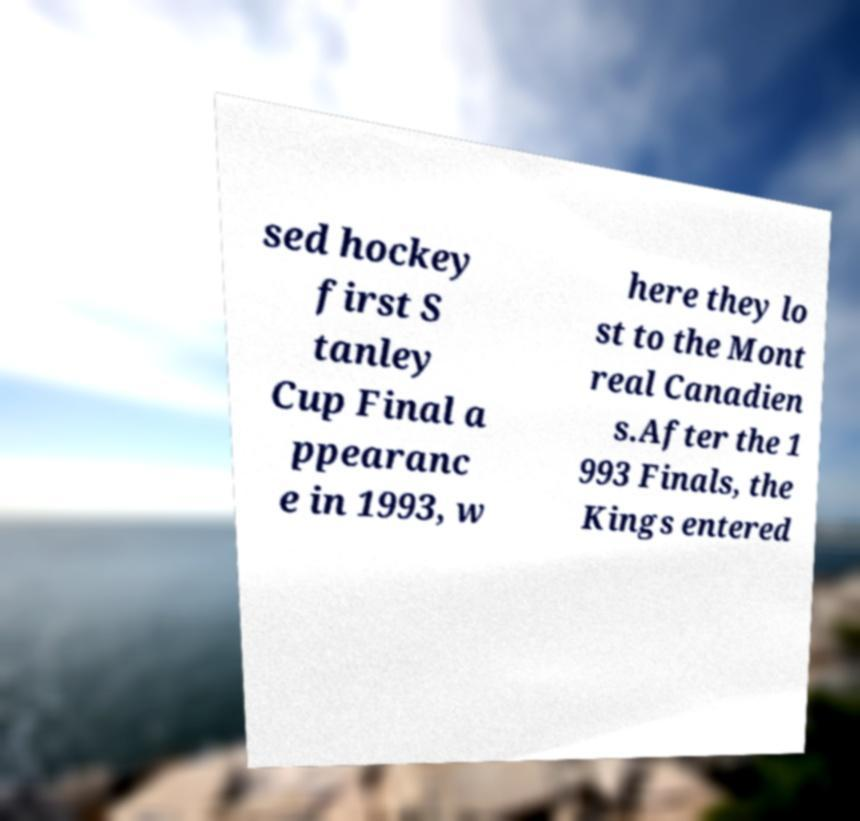Please read and relay the text visible in this image. What does it say? sed hockey first S tanley Cup Final a ppearanc e in 1993, w here they lo st to the Mont real Canadien s.After the 1 993 Finals, the Kings entered 